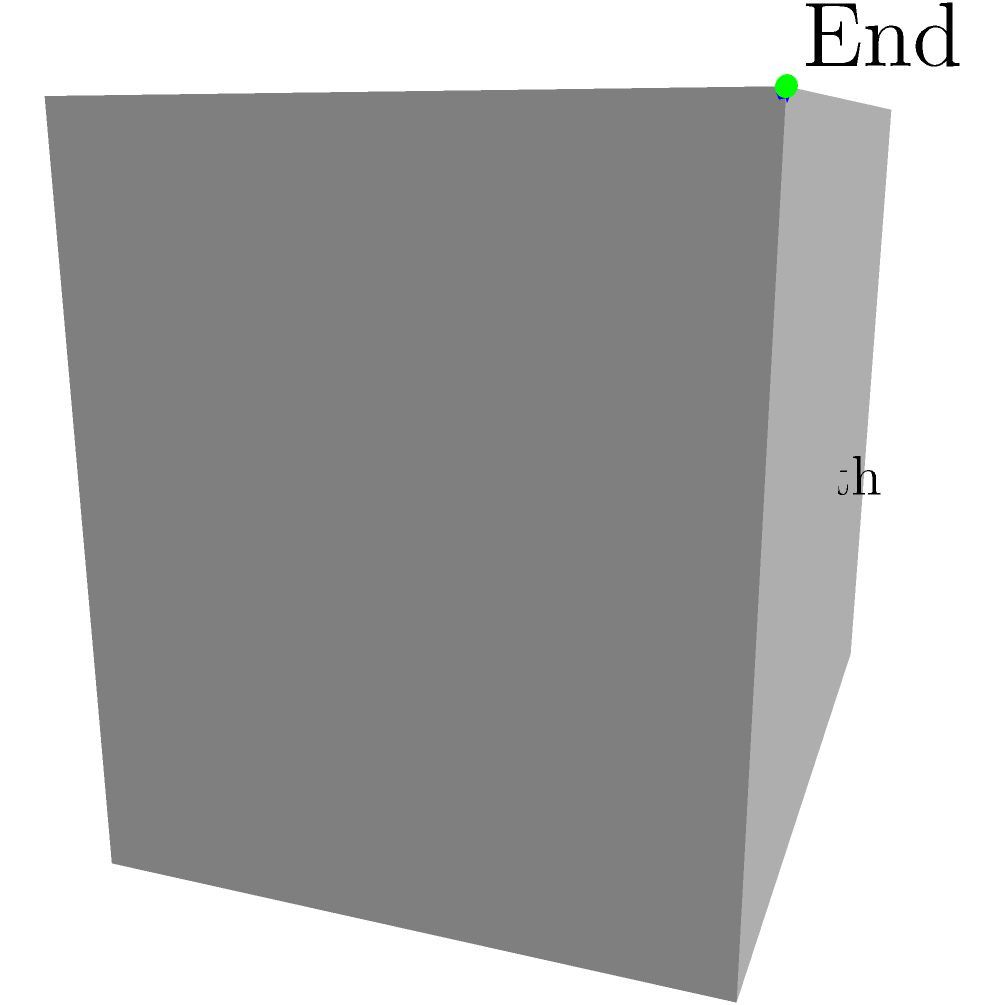In a 3D game environment developed using Urho3D, you want to implement reinforcement learning to optimize pathfinding. Given the diagram showing a suboptimal path (solid blue line) and an optimal path (dashed red line) between start and end points, which key component of reinforcement learning would be most crucial in training an agent to find the optimal path? To optimize pathfinding using reinforcement learning in a 3D game environment, we need to consider the following steps:

1. State representation: The agent's current position in the 3D space.
2. Action space: Possible movements in the 3D environment (e.g., up, down, left, right, forward, backward).
3. Reward function: Encourages efficient pathfinding.
4. Q-function or policy: Determines the best action to take in each state.

The most crucial component for this specific problem is the reward function. Here's why:

1. The reward function shapes the agent's behavior by providing feedback on its actions.
2. For pathfinding, we want to encourage shorter paths and penalize longer ones.
3. A well-designed reward function would give higher rewards for actions that move the agent closer to the goal and lower rewards or penalties for actions that move it away or cause unnecessary detours.
4. The reward function helps the agent learn to differentiate between the suboptimal path (solid blue line) and the optimal path (dashed red line).
5. By maximizing cumulative rewards, the agent will learn to prefer the optimal path over time.

Other components are also important, but the reward function is the key to guiding the agent towards finding the optimal path in this scenario.
Answer: Reward function 